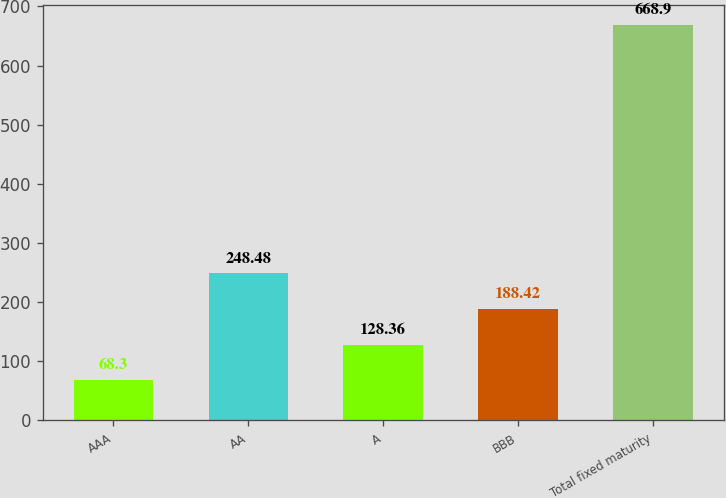Convert chart. <chart><loc_0><loc_0><loc_500><loc_500><bar_chart><fcel>AAA<fcel>AA<fcel>A<fcel>BBB<fcel>Total fixed maturity<nl><fcel>68.3<fcel>248.48<fcel>128.36<fcel>188.42<fcel>668.9<nl></chart> 